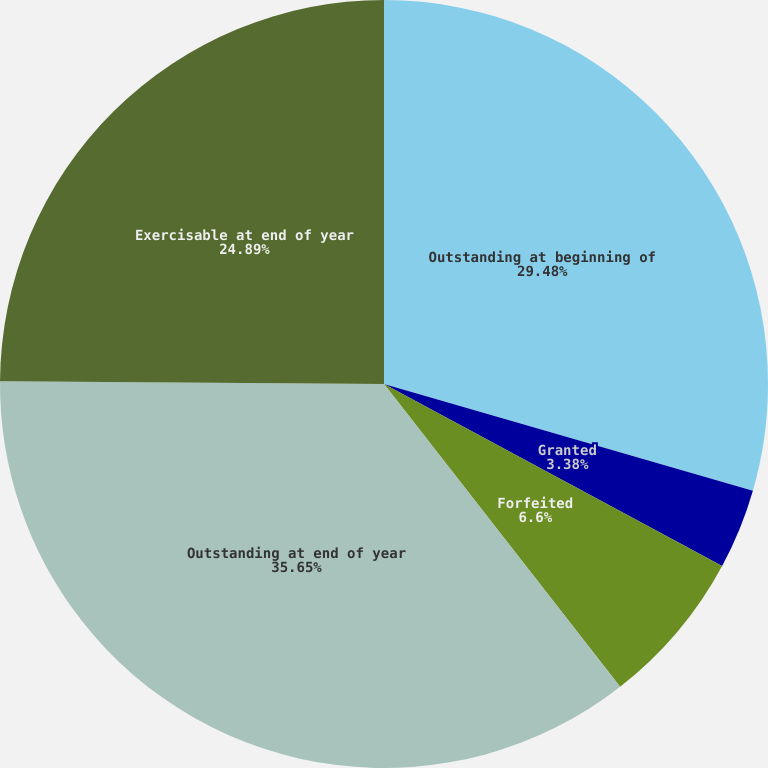Convert chart to OTSL. <chart><loc_0><loc_0><loc_500><loc_500><pie_chart><fcel>Outstanding at beginning of<fcel>Granted<fcel>Forfeited<fcel>Outstanding at end of year<fcel>Exercisable at end of year<nl><fcel>29.48%<fcel>3.38%<fcel>6.6%<fcel>35.65%<fcel>24.89%<nl></chart> 